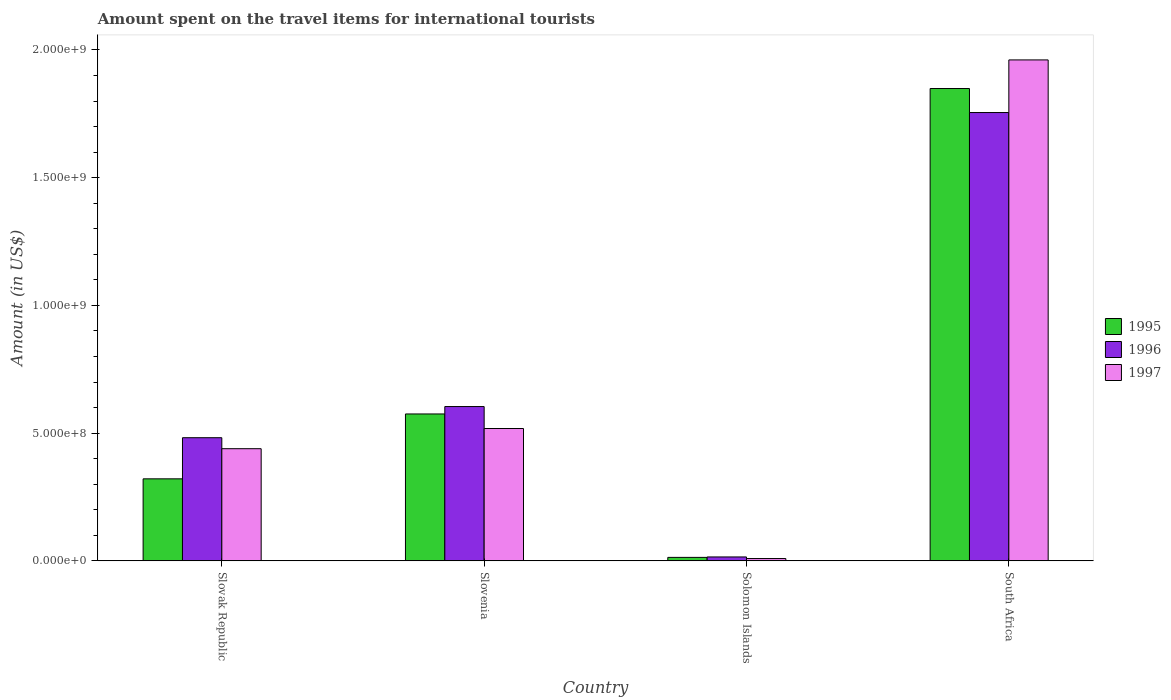How many different coloured bars are there?
Offer a terse response. 3. How many groups of bars are there?
Your answer should be very brief. 4. Are the number of bars per tick equal to the number of legend labels?
Provide a succinct answer. Yes. How many bars are there on the 3rd tick from the left?
Offer a terse response. 3. How many bars are there on the 4th tick from the right?
Ensure brevity in your answer.  3. What is the label of the 3rd group of bars from the left?
Keep it short and to the point. Solomon Islands. In how many cases, is the number of bars for a given country not equal to the number of legend labels?
Your answer should be very brief. 0. What is the amount spent on the travel items for international tourists in 1995 in Slovenia?
Your answer should be compact. 5.75e+08. Across all countries, what is the maximum amount spent on the travel items for international tourists in 1995?
Make the answer very short. 1.85e+09. Across all countries, what is the minimum amount spent on the travel items for international tourists in 1996?
Give a very brief answer. 1.52e+07. In which country was the amount spent on the travel items for international tourists in 1997 maximum?
Make the answer very short. South Africa. In which country was the amount spent on the travel items for international tourists in 1997 minimum?
Keep it short and to the point. Solomon Islands. What is the total amount spent on the travel items for international tourists in 1997 in the graph?
Offer a terse response. 2.93e+09. What is the difference between the amount spent on the travel items for international tourists in 1997 in Solomon Islands and that in South Africa?
Provide a succinct answer. -1.95e+09. What is the difference between the amount spent on the travel items for international tourists in 1995 in South Africa and the amount spent on the travel items for international tourists in 1996 in Slovenia?
Your answer should be very brief. 1.24e+09. What is the average amount spent on the travel items for international tourists in 1996 per country?
Make the answer very short. 7.14e+08. What is the difference between the amount spent on the travel items for international tourists of/in 1995 and amount spent on the travel items for international tourists of/in 1997 in Slovenia?
Ensure brevity in your answer.  5.70e+07. What is the ratio of the amount spent on the travel items for international tourists in 1995 in Solomon Islands to that in South Africa?
Provide a short and direct response. 0.01. Is the amount spent on the travel items for international tourists in 1997 in Slovak Republic less than that in Slovenia?
Offer a terse response. Yes. What is the difference between the highest and the second highest amount spent on the travel items for international tourists in 1997?
Offer a very short reply. 1.44e+09. What is the difference between the highest and the lowest amount spent on the travel items for international tourists in 1997?
Provide a succinct answer. 1.95e+09. Is the sum of the amount spent on the travel items for international tourists in 1996 in Slovenia and Solomon Islands greater than the maximum amount spent on the travel items for international tourists in 1997 across all countries?
Give a very brief answer. No. How many bars are there?
Ensure brevity in your answer.  12. Are all the bars in the graph horizontal?
Offer a terse response. No. What is the difference between two consecutive major ticks on the Y-axis?
Offer a terse response. 5.00e+08. Does the graph contain any zero values?
Provide a succinct answer. No. Does the graph contain grids?
Keep it short and to the point. No. Where does the legend appear in the graph?
Your answer should be very brief. Center right. How many legend labels are there?
Offer a very short reply. 3. How are the legend labels stacked?
Your answer should be compact. Vertical. What is the title of the graph?
Keep it short and to the point. Amount spent on the travel items for international tourists. What is the label or title of the X-axis?
Ensure brevity in your answer.  Country. What is the label or title of the Y-axis?
Your answer should be very brief. Amount (in US$). What is the Amount (in US$) of 1995 in Slovak Republic?
Provide a succinct answer. 3.21e+08. What is the Amount (in US$) of 1996 in Slovak Republic?
Make the answer very short. 4.82e+08. What is the Amount (in US$) of 1997 in Slovak Republic?
Make the answer very short. 4.39e+08. What is the Amount (in US$) in 1995 in Slovenia?
Offer a very short reply. 5.75e+08. What is the Amount (in US$) in 1996 in Slovenia?
Offer a very short reply. 6.04e+08. What is the Amount (in US$) of 1997 in Slovenia?
Ensure brevity in your answer.  5.18e+08. What is the Amount (in US$) of 1995 in Solomon Islands?
Offer a very short reply. 1.35e+07. What is the Amount (in US$) in 1996 in Solomon Islands?
Give a very brief answer. 1.52e+07. What is the Amount (in US$) of 1997 in Solomon Islands?
Offer a terse response. 9.00e+06. What is the Amount (in US$) in 1995 in South Africa?
Keep it short and to the point. 1.85e+09. What is the Amount (in US$) of 1996 in South Africa?
Your answer should be very brief. 1.76e+09. What is the Amount (in US$) of 1997 in South Africa?
Provide a succinct answer. 1.96e+09. Across all countries, what is the maximum Amount (in US$) in 1995?
Your response must be concise. 1.85e+09. Across all countries, what is the maximum Amount (in US$) of 1996?
Make the answer very short. 1.76e+09. Across all countries, what is the maximum Amount (in US$) in 1997?
Your answer should be compact. 1.96e+09. Across all countries, what is the minimum Amount (in US$) in 1995?
Offer a terse response. 1.35e+07. Across all countries, what is the minimum Amount (in US$) of 1996?
Your answer should be compact. 1.52e+07. Across all countries, what is the minimum Amount (in US$) in 1997?
Give a very brief answer. 9.00e+06. What is the total Amount (in US$) of 1995 in the graph?
Offer a very short reply. 2.76e+09. What is the total Amount (in US$) of 1996 in the graph?
Ensure brevity in your answer.  2.86e+09. What is the total Amount (in US$) of 1997 in the graph?
Your answer should be very brief. 2.93e+09. What is the difference between the Amount (in US$) in 1995 in Slovak Republic and that in Slovenia?
Make the answer very short. -2.54e+08. What is the difference between the Amount (in US$) of 1996 in Slovak Republic and that in Slovenia?
Ensure brevity in your answer.  -1.22e+08. What is the difference between the Amount (in US$) of 1997 in Slovak Republic and that in Slovenia?
Make the answer very short. -7.90e+07. What is the difference between the Amount (in US$) of 1995 in Slovak Republic and that in Solomon Islands?
Give a very brief answer. 3.08e+08. What is the difference between the Amount (in US$) of 1996 in Slovak Republic and that in Solomon Islands?
Ensure brevity in your answer.  4.67e+08. What is the difference between the Amount (in US$) of 1997 in Slovak Republic and that in Solomon Islands?
Provide a succinct answer. 4.30e+08. What is the difference between the Amount (in US$) of 1995 in Slovak Republic and that in South Africa?
Offer a very short reply. -1.53e+09. What is the difference between the Amount (in US$) in 1996 in Slovak Republic and that in South Africa?
Give a very brief answer. -1.27e+09. What is the difference between the Amount (in US$) of 1997 in Slovak Republic and that in South Africa?
Offer a terse response. -1.52e+09. What is the difference between the Amount (in US$) of 1995 in Slovenia and that in Solomon Islands?
Offer a terse response. 5.62e+08. What is the difference between the Amount (in US$) of 1996 in Slovenia and that in Solomon Islands?
Ensure brevity in your answer.  5.89e+08. What is the difference between the Amount (in US$) of 1997 in Slovenia and that in Solomon Islands?
Your answer should be very brief. 5.09e+08. What is the difference between the Amount (in US$) of 1995 in Slovenia and that in South Africa?
Give a very brief answer. -1.27e+09. What is the difference between the Amount (in US$) in 1996 in Slovenia and that in South Africa?
Make the answer very short. -1.15e+09. What is the difference between the Amount (in US$) of 1997 in Slovenia and that in South Africa?
Your answer should be compact. -1.44e+09. What is the difference between the Amount (in US$) in 1995 in Solomon Islands and that in South Africa?
Offer a terse response. -1.84e+09. What is the difference between the Amount (in US$) of 1996 in Solomon Islands and that in South Africa?
Offer a terse response. -1.74e+09. What is the difference between the Amount (in US$) of 1997 in Solomon Islands and that in South Africa?
Ensure brevity in your answer.  -1.95e+09. What is the difference between the Amount (in US$) in 1995 in Slovak Republic and the Amount (in US$) in 1996 in Slovenia?
Provide a short and direct response. -2.83e+08. What is the difference between the Amount (in US$) of 1995 in Slovak Republic and the Amount (in US$) of 1997 in Slovenia?
Offer a very short reply. -1.97e+08. What is the difference between the Amount (in US$) in 1996 in Slovak Republic and the Amount (in US$) in 1997 in Slovenia?
Provide a short and direct response. -3.60e+07. What is the difference between the Amount (in US$) in 1995 in Slovak Republic and the Amount (in US$) in 1996 in Solomon Islands?
Provide a short and direct response. 3.06e+08. What is the difference between the Amount (in US$) of 1995 in Slovak Republic and the Amount (in US$) of 1997 in Solomon Islands?
Your response must be concise. 3.12e+08. What is the difference between the Amount (in US$) of 1996 in Slovak Republic and the Amount (in US$) of 1997 in Solomon Islands?
Keep it short and to the point. 4.73e+08. What is the difference between the Amount (in US$) in 1995 in Slovak Republic and the Amount (in US$) in 1996 in South Africa?
Make the answer very short. -1.43e+09. What is the difference between the Amount (in US$) in 1995 in Slovak Republic and the Amount (in US$) in 1997 in South Africa?
Offer a terse response. -1.64e+09. What is the difference between the Amount (in US$) in 1996 in Slovak Republic and the Amount (in US$) in 1997 in South Africa?
Give a very brief answer. -1.48e+09. What is the difference between the Amount (in US$) in 1995 in Slovenia and the Amount (in US$) in 1996 in Solomon Islands?
Offer a very short reply. 5.60e+08. What is the difference between the Amount (in US$) in 1995 in Slovenia and the Amount (in US$) in 1997 in Solomon Islands?
Provide a short and direct response. 5.66e+08. What is the difference between the Amount (in US$) in 1996 in Slovenia and the Amount (in US$) in 1997 in Solomon Islands?
Offer a very short reply. 5.95e+08. What is the difference between the Amount (in US$) in 1995 in Slovenia and the Amount (in US$) in 1996 in South Africa?
Your answer should be very brief. -1.18e+09. What is the difference between the Amount (in US$) in 1995 in Slovenia and the Amount (in US$) in 1997 in South Africa?
Your response must be concise. -1.39e+09. What is the difference between the Amount (in US$) of 1996 in Slovenia and the Amount (in US$) of 1997 in South Africa?
Offer a very short reply. -1.36e+09. What is the difference between the Amount (in US$) of 1995 in Solomon Islands and the Amount (in US$) of 1996 in South Africa?
Your answer should be very brief. -1.74e+09. What is the difference between the Amount (in US$) in 1995 in Solomon Islands and the Amount (in US$) in 1997 in South Africa?
Your answer should be compact. -1.95e+09. What is the difference between the Amount (in US$) of 1996 in Solomon Islands and the Amount (in US$) of 1997 in South Africa?
Keep it short and to the point. -1.95e+09. What is the average Amount (in US$) in 1995 per country?
Keep it short and to the point. 6.90e+08. What is the average Amount (in US$) in 1996 per country?
Offer a very short reply. 7.14e+08. What is the average Amount (in US$) in 1997 per country?
Your response must be concise. 7.32e+08. What is the difference between the Amount (in US$) in 1995 and Amount (in US$) in 1996 in Slovak Republic?
Make the answer very short. -1.61e+08. What is the difference between the Amount (in US$) in 1995 and Amount (in US$) in 1997 in Slovak Republic?
Your answer should be compact. -1.18e+08. What is the difference between the Amount (in US$) of 1996 and Amount (in US$) of 1997 in Slovak Republic?
Keep it short and to the point. 4.30e+07. What is the difference between the Amount (in US$) of 1995 and Amount (in US$) of 1996 in Slovenia?
Your response must be concise. -2.90e+07. What is the difference between the Amount (in US$) of 1995 and Amount (in US$) of 1997 in Slovenia?
Your answer should be compact. 5.70e+07. What is the difference between the Amount (in US$) in 1996 and Amount (in US$) in 1997 in Slovenia?
Provide a short and direct response. 8.60e+07. What is the difference between the Amount (in US$) of 1995 and Amount (in US$) of 1996 in Solomon Islands?
Offer a terse response. -1.70e+06. What is the difference between the Amount (in US$) of 1995 and Amount (in US$) of 1997 in Solomon Islands?
Give a very brief answer. 4.50e+06. What is the difference between the Amount (in US$) in 1996 and Amount (in US$) in 1997 in Solomon Islands?
Your answer should be compact. 6.20e+06. What is the difference between the Amount (in US$) in 1995 and Amount (in US$) in 1996 in South Africa?
Provide a succinct answer. 9.40e+07. What is the difference between the Amount (in US$) in 1995 and Amount (in US$) in 1997 in South Africa?
Your answer should be very brief. -1.12e+08. What is the difference between the Amount (in US$) of 1996 and Amount (in US$) of 1997 in South Africa?
Give a very brief answer. -2.06e+08. What is the ratio of the Amount (in US$) in 1995 in Slovak Republic to that in Slovenia?
Provide a short and direct response. 0.56. What is the ratio of the Amount (in US$) in 1996 in Slovak Republic to that in Slovenia?
Your answer should be compact. 0.8. What is the ratio of the Amount (in US$) in 1997 in Slovak Republic to that in Slovenia?
Keep it short and to the point. 0.85. What is the ratio of the Amount (in US$) in 1995 in Slovak Republic to that in Solomon Islands?
Ensure brevity in your answer.  23.78. What is the ratio of the Amount (in US$) in 1996 in Slovak Republic to that in Solomon Islands?
Make the answer very short. 31.71. What is the ratio of the Amount (in US$) of 1997 in Slovak Republic to that in Solomon Islands?
Your answer should be compact. 48.78. What is the ratio of the Amount (in US$) of 1995 in Slovak Republic to that in South Africa?
Provide a succinct answer. 0.17. What is the ratio of the Amount (in US$) of 1996 in Slovak Republic to that in South Africa?
Keep it short and to the point. 0.27. What is the ratio of the Amount (in US$) of 1997 in Slovak Republic to that in South Africa?
Provide a short and direct response. 0.22. What is the ratio of the Amount (in US$) of 1995 in Slovenia to that in Solomon Islands?
Keep it short and to the point. 42.59. What is the ratio of the Amount (in US$) in 1996 in Slovenia to that in Solomon Islands?
Offer a very short reply. 39.74. What is the ratio of the Amount (in US$) of 1997 in Slovenia to that in Solomon Islands?
Make the answer very short. 57.56. What is the ratio of the Amount (in US$) of 1995 in Slovenia to that in South Africa?
Give a very brief answer. 0.31. What is the ratio of the Amount (in US$) in 1996 in Slovenia to that in South Africa?
Offer a very short reply. 0.34. What is the ratio of the Amount (in US$) in 1997 in Slovenia to that in South Africa?
Your answer should be very brief. 0.26. What is the ratio of the Amount (in US$) of 1995 in Solomon Islands to that in South Africa?
Provide a short and direct response. 0.01. What is the ratio of the Amount (in US$) in 1996 in Solomon Islands to that in South Africa?
Offer a very short reply. 0.01. What is the ratio of the Amount (in US$) of 1997 in Solomon Islands to that in South Africa?
Keep it short and to the point. 0. What is the difference between the highest and the second highest Amount (in US$) in 1995?
Offer a very short reply. 1.27e+09. What is the difference between the highest and the second highest Amount (in US$) of 1996?
Offer a very short reply. 1.15e+09. What is the difference between the highest and the second highest Amount (in US$) in 1997?
Make the answer very short. 1.44e+09. What is the difference between the highest and the lowest Amount (in US$) of 1995?
Make the answer very short. 1.84e+09. What is the difference between the highest and the lowest Amount (in US$) in 1996?
Give a very brief answer. 1.74e+09. What is the difference between the highest and the lowest Amount (in US$) in 1997?
Offer a very short reply. 1.95e+09. 